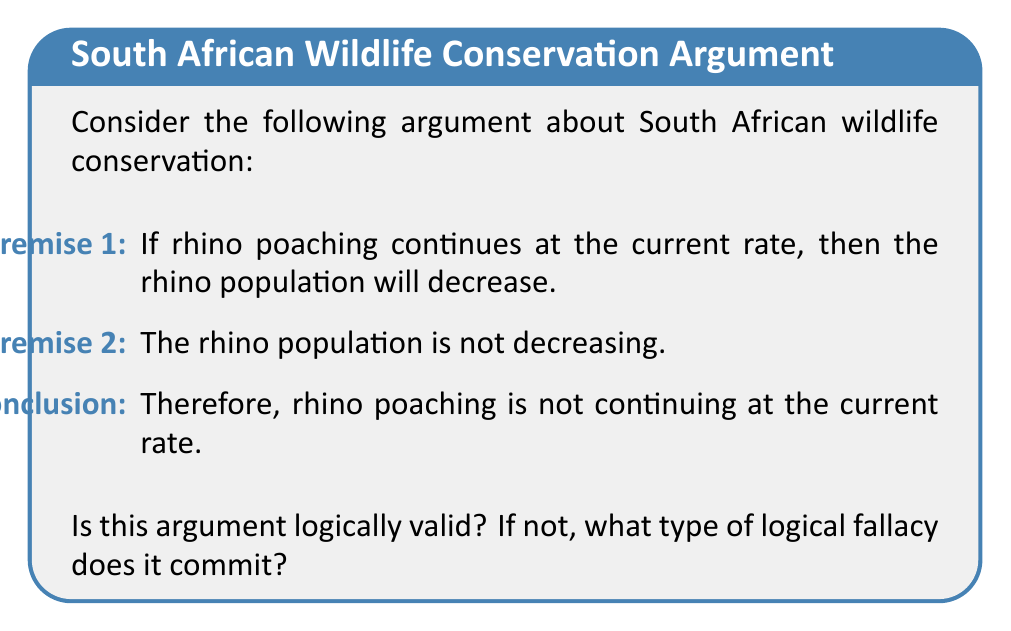Help me with this question. To determine the logical validity of this argument, we need to analyze its structure. Let's break it down step-by-step:

1. First, let's assign symbols to our statements:
   P: Rhino poaching continues at the current rate
   Q: The rhino population will decrease

2. Now, we can rewrite the argument in symbolic form:
   Premise 1: $P \rightarrow Q$ (If P, then Q)
   Premise 2: $\neg Q$ (Not Q)
   Conclusion: $\therefore \neg P$ (Therefore, not P)

3. This argument form is known as Modus Tollens (denying the consequent), which has the general structure:
   $$\frac{P \rightarrow Q, \neg Q}{\therefore \neg P}$$

4. Modus Tollens is a valid argument form in propositional logic. It states that if we have a conditional statement "if P, then Q" and we know that Q is false, we can conclude that P must also be false.

5. In this case, we're given that if poaching continues (P), then the population will decrease (Q). We're also told that the population is not decreasing (not Q). Following the Modus Tollens rule, we can validly conclude that poaching is not continuing at the current rate (not P).

6. It's important to note that while this argument is logically valid, it doesn't necessarily mean the conclusion is true in reality. The validity of an argument only ensures that if the premises are true, the conclusion must be true. The actual truth of the premises should be verified separately.

Therefore, this argument is logically valid and does not commit a logical fallacy.
Answer: Valid; Modus Tollens 